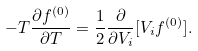<formula> <loc_0><loc_0><loc_500><loc_500>- T \frac { \partial f ^ { ( 0 ) } } { \partial T } = \frac { 1 } { 2 } \frac { \partial } { \partial V _ { i } } [ V _ { i } f ^ { ( 0 ) } ] .</formula> 